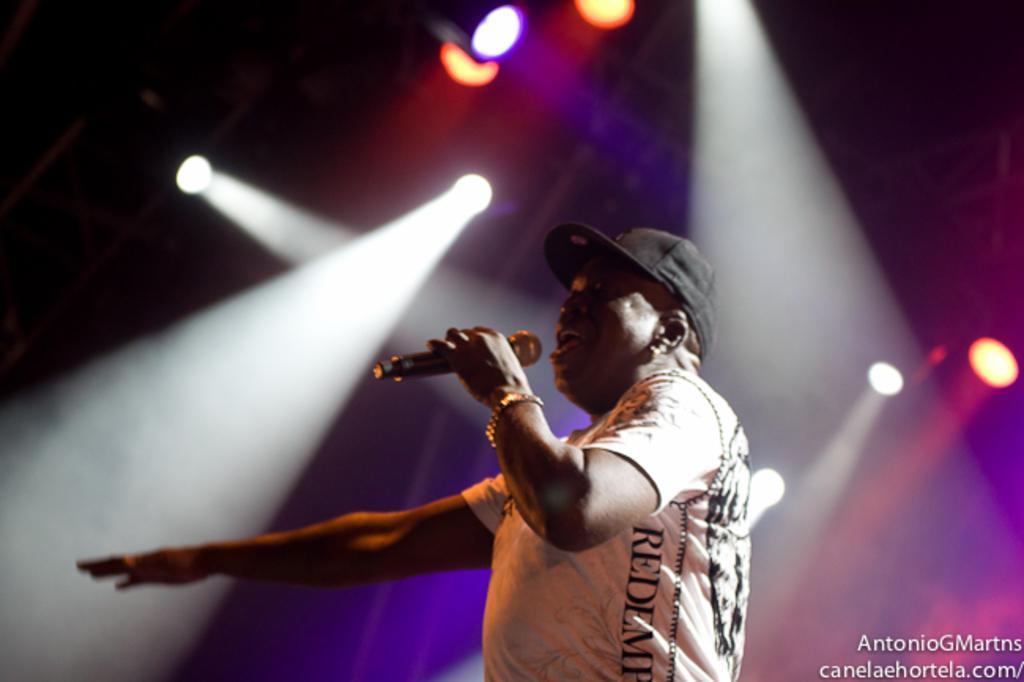Could you give a brief overview of what you see in this image? In the image there is a man standing, he is wearing a bracelet to his left hand , he is singing a song he is also wearing black color hat, in the background there are lot of different colors of lights. 